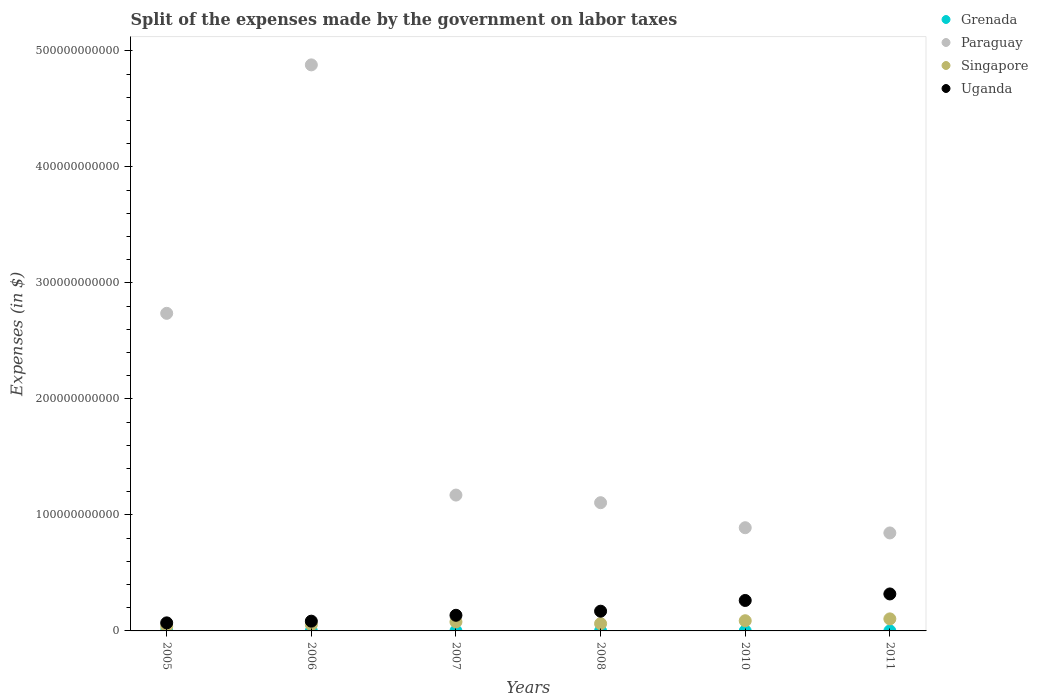What is the expenses made by the government on labor taxes in Grenada in 2008?
Your answer should be very brief. 2.60e+07. Across all years, what is the maximum expenses made by the government on labor taxes in Uganda?
Your response must be concise. 3.19e+1. Across all years, what is the minimum expenses made by the government on labor taxes in Grenada?
Provide a succinct answer. 1.49e+07. In which year was the expenses made by the government on labor taxes in Uganda maximum?
Ensure brevity in your answer.  2011. What is the total expenses made by the government on labor taxes in Paraguay in the graph?
Offer a terse response. 1.16e+12. What is the difference between the expenses made by the government on labor taxes in Singapore in 2008 and that in 2010?
Provide a short and direct response. -2.52e+09. What is the difference between the expenses made by the government on labor taxes in Paraguay in 2011 and the expenses made by the government on labor taxes in Uganda in 2005?
Keep it short and to the point. 7.75e+1. What is the average expenses made by the government on labor taxes in Paraguay per year?
Your answer should be very brief. 1.94e+11. In the year 2005, what is the difference between the expenses made by the government on labor taxes in Grenada and expenses made by the government on labor taxes in Singapore?
Your answer should be compact. -3.87e+09. In how many years, is the expenses made by the government on labor taxes in Grenada greater than 400000000000 $?
Give a very brief answer. 0. What is the ratio of the expenses made by the government on labor taxes in Paraguay in 2008 to that in 2011?
Make the answer very short. 1.31. Is the expenses made by the government on labor taxes in Singapore in 2010 less than that in 2011?
Your answer should be compact. Yes. What is the difference between the highest and the second highest expenses made by the government on labor taxes in Uganda?
Give a very brief answer. 5.62e+09. What is the difference between the highest and the lowest expenses made by the government on labor taxes in Paraguay?
Your answer should be very brief. 4.04e+11. Is it the case that in every year, the sum of the expenses made by the government on labor taxes in Singapore and expenses made by the government on labor taxes in Grenada  is greater than the sum of expenses made by the government on labor taxes in Uganda and expenses made by the government on labor taxes in Paraguay?
Offer a very short reply. No. Is it the case that in every year, the sum of the expenses made by the government on labor taxes in Paraguay and expenses made by the government on labor taxes in Uganda  is greater than the expenses made by the government on labor taxes in Grenada?
Offer a very short reply. Yes. Does the expenses made by the government on labor taxes in Grenada monotonically increase over the years?
Offer a terse response. No. Is the expenses made by the government on labor taxes in Grenada strictly less than the expenses made by the government on labor taxes in Uganda over the years?
Offer a very short reply. Yes. How many dotlines are there?
Ensure brevity in your answer.  4. How many years are there in the graph?
Your response must be concise. 6. What is the difference between two consecutive major ticks on the Y-axis?
Your answer should be compact. 1.00e+11. Are the values on the major ticks of Y-axis written in scientific E-notation?
Make the answer very short. No. How are the legend labels stacked?
Offer a terse response. Vertical. What is the title of the graph?
Your answer should be very brief. Split of the expenses made by the government on labor taxes. What is the label or title of the X-axis?
Your response must be concise. Years. What is the label or title of the Y-axis?
Offer a terse response. Expenses (in $). What is the Expenses (in $) in Grenada in 2005?
Your response must be concise. 1.54e+07. What is the Expenses (in $) of Paraguay in 2005?
Your answer should be very brief. 2.74e+11. What is the Expenses (in $) in Singapore in 2005?
Make the answer very short. 3.89e+09. What is the Expenses (in $) of Uganda in 2005?
Your answer should be very brief. 6.95e+09. What is the Expenses (in $) in Grenada in 2006?
Your response must be concise. 2.26e+07. What is the Expenses (in $) in Paraguay in 2006?
Provide a succinct answer. 4.88e+11. What is the Expenses (in $) in Singapore in 2006?
Provide a short and direct response. 5.35e+09. What is the Expenses (in $) of Uganda in 2006?
Provide a short and direct response. 8.41e+09. What is the Expenses (in $) in Grenada in 2007?
Your answer should be compact. 2.90e+07. What is the Expenses (in $) of Paraguay in 2007?
Your response must be concise. 1.17e+11. What is the Expenses (in $) in Singapore in 2007?
Make the answer very short. 7.79e+09. What is the Expenses (in $) of Uganda in 2007?
Your response must be concise. 1.35e+1. What is the Expenses (in $) in Grenada in 2008?
Provide a short and direct response. 2.60e+07. What is the Expenses (in $) of Paraguay in 2008?
Your answer should be very brief. 1.11e+11. What is the Expenses (in $) in Singapore in 2008?
Provide a succinct answer. 6.26e+09. What is the Expenses (in $) in Uganda in 2008?
Give a very brief answer. 1.70e+1. What is the Expenses (in $) in Grenada in 2010?
Provide a succinct answer. 1.74e+07. What is the Expenses (in $) of Paraguay in 2010?
Provide a short and direct response. 8.90e+1. What is the Expenses (in $) of Singapore in 2010?
Offer a terse response. 8.79e+09. What is the Expenses (in $) of Uganda in 2010?
Provide a short and direct response. 2.63e+1. What is the Expenses (in $) in Grenada in 2011?
Keep it short and to the point. 1.49e+07. What is the Expenses (in $) of Paraguay in 2011?
Provide a succinct answer. 8.45e+1. What is the Expenses (in $) in Singapore in 2011?
Keep it short and to the point. 1.04e+1. What is the Expenses (in $) of Uganda in 2011?
Make the answer very short. 3.19e+1. Across all years, what is the maximum Expenses (in $) of Grenada?
Provide a succinct answer. 2.90e+07. Across all years, what is the maximum Expenses (in $) in Paraguay?
Offer a very short reply. 4.88e+11. Across all years, what is the maximum Expenses (in $) of Singapore?
Ensure brevity in your answer.  1.04e+1. Across all years, what is the maximum Expenses (in $) in Uganda?
Your answer should be very brief. 3.19e+1. Across all years, what is the minimum Expenses (in $) in Grenada?
Your answer should be very brief. 1.49e+07. Across all years, what is the minimum Expenses (in $) in Paraguay?
Provide a succinct answer. 8.45e+1. Across all years, what is the minimum Expenses (in $) of Singapore?
Make the answer very short. 3.89e+09. Across all years, what is the minimum Expenses (in $) of Uganda?
Provide a succinct answer. 6.95e+09. What is the total Expenses (in $) in Grenada in the graph?
Provide a succinct answer. 1.25e+08. What is the total Expenses (in $) in Paraguay in the graph?
Keep it short and to the point. 1.16e+12. What is the total Expenses (in $) in Singapore in the graph?
Keep it short and to the point. 4.25e+1. What is the total Expenses (in $) in Uganda in the graph?
Ensure brevity in your answer.  1.04e+11. What is the difference between the Expenses (in $) in Grenada in 2005 and that in 2006?
Keep it short and to the point. -7.20e+06. What is the difference between the Expenses (in $) in Paraguay in 2005 and that in 2006?
Provide a short and direct response. -2.14e+11. What is the difference between the Expenses (in $) in Singapore in 2005 and that in 2006?
Your answer should be compact. -1.46e+09. What is the difference between the Expenses (in $) of Uganda in 2005 and that in 2006?
Make the answer very short. -1.47e+09. What is the difference between the Expenses (in $) in Grenada in 2005 and that in 2007?
Offer a very short reply. -1.36e+07. What is the difference between the Expenses (in $) of Paraguay in 2005 and that in 2007?
Keep it short and to the point. 1.57e+11. What is the difference between the Expenses (in $) of Singapore in 2005 and that in 2007?
Offer a terse response. -3.90e+09. What is the difference between the Expenses (in $) of Uganda in 2005 and that in 2007?
Keep it short and to the point. -6.53e+09. What is the difference between the Expenses (in $) in Grenada in 2005 and that in 2008?
Provide a short and direct response. -1.06e+07. What is the difference between the Expenses (in $) of Paraguay in 2005 and that in 2008?
Offer a terse response. 1.63e+11. What is the difference between the Expenses (in $) of Singapore in 2005 and that in 2008?
Your answer should be compact. -2.37e+09. What is the difference between the Expenses (in $) of Uganda in 2005 and that in 2008?
Your answer should be compact. -1.01e+1. What is the difference between the Expenses (in $) of Paraguay in 2005 and that in 2010?
Provide a short and direct response. 1.85e+11. What is the difference between the Expenses (in $) of Singapore in 2005 and that in 2010?
Provide a short and direct response. -4.90e+09. What is the difference between the Expenses (in $) in Uganda in 2005 and that in 2010?
Keep it short and to the point. -1.93e+1. What is the difference between the Expenses (in $) in Grenada in 2005 and that in 2011?
Offer a very short reply. 5.00e+05. What is the difference between the Expenses (in $) of Paraguay in 2005 and that in 2011?
Provide a succinct answer. 1.89e+11. What is the difference between the Expenses (in $) of Singapore in 2005 and that in 2011?
Make the answer very short. -6.49e+09. What is the difference between the Expenses (in $) of Uganda in 2005 and that in 2011?
Your answer should be compact. -2.49e+1. What is the difference between the Expenses (in $) of Grenada in 2006 and that in 2007?
Your answer should be very brief. -6.40e+06. What is the difference between the Expenses (in $) of Paraguay in 2006 and that in 2007?
Make the answer very short. 3.71e+11. What is the difference between the Expenses (in $) of Singapore in 2006 and that in 2007?
Give a very brief answer. -2.44e+09. What is the difference between the Expenses (in $) in Uganda in 2006 and that in 2007?
Offer a terse response. -5.06e+09. What is the difference between the Expenses (in $) of Grenada in 2006 and that in 2008?
Your answer should be very brief. -3.40e+06. What is the difference between the Expenses (in $) in Paraguay in 2006 and that in 2008?
Give a very brief answer. 3.77e+11. What is the difference between the Expenses (in $) of Singapore in 2006 and that in 2008?
Provide a succinct answer. -9.17e+08. What is the difference between the Expenses (in $) of Uganda in 2006 and that in 2008?
Offer a terse response. -8.60e+09. What is the difference between the Expenses (in $) of Grenada in 2006 and that in 2010?
Your response must be concise. 5.20e+06. What is the difference between the Expenses (in $) in Paraguay in 2006 and that in 2010?
Your answer should be compact. 3.99e+11. What is the difference between the Expenses (in $) of Singapore in 2006 and that in 2010?
Offer a very short reply. -3.44e+09. What is the difference between the Expenses (in $) in Uganda in 2006 and that in 2010?
Offer a terse response. -1.78e+1. What is the difference between the Expenses (in $) in Grenada in 2006 and that in 2011?
Your answer should be compact. 7.70e+06. What is the difference between the Expenses (in $) in Paraguay in 2006 and that in 2011?
Offer a very short reply. 4.04e+11. What is the difference between the Expenses (in $) in Singapore in 2006 and that in 2011?
Provide a short and direct response. -5.04e+09. What is the difference between the Expenses (in $) in Uganda in 2006 and that in 2011?
Give a very brief answer. -2.35e+1. What is the difference between the Expenses (in $) in Paraguay in 2007 and that in 2008?
Ensure brevity in your answer.  6.57e+09. What is the difference between the Expenses (in $) in Singapore in 2007 and that in 2008?
Your response must be concise. 1.53e+09. What is the difference between the Expenses (in $) in Uganda in 2007 and that in 2008?
Offer a very short reply. -3.54e+09. What is the difference between the Expenses (in $) of Grenada in 2007 and that in 2010?
Offer a terse response. 1.16e+07. What is the difference between the Expenses (in $) of Paraguay in 2007 and that in 2010?
Ensure brevity in your answer.  2.81e+1. What is the difference between the Expenses (in $) of Singapore in 2007 and that in 2010?
Give a very brief answer. -9.95e+08. What is the difference between the Expenses (in $) in Uganda in 2007 and that in 2010?
Keep it short and to the point. -1.28e+1. What is the difference between the Expenses (in $) in Grenada in 2007 and that in 2011?
Make the answer very short. 1.41e+07. What is the difference between the Expenses (in $) in Paraguay in 2007 and that in 2011?
Provide a short and direct response. 3.26e+1. What is the difference between the Expenses (in $) of Singapore in 2007 and that in 2011?
Your answer should be compact. -2.59e+09. What is the difference between the Expenses (in $) of Uganda in 2007 and that in 2011?
Ensure brevity in your answer.  -1.84e+1. What is the difference between the Expenses (in $) in Grenada in 2008 and that in 2010?
Keep it short and to the point. 8.60e+06. What is the difference between the Expenses (in $) in Paraguay in 2008 and that in 2010?
Provide a succinct answer. 2.16e+1. What is the difference between the Expenses (in $) in Singapore in 2008 and that in 2010?
Give a very brief answer. -2.52e+09. What is the difference between the Expenses (in $) of Uganda in 2008 and that in 2010?
Make the answer very short. -9.25e+09. What is the difference between the Expenses (in $) in Grenada in 2008 and that in 2011?
Make the answer very short. 1.11e+07. What is the difference between the Expenses (in $) of Paraguay in 2008 and that in 2011?
Make the answer very short. 2.61e+1. What is the difference between the Expenses (in $) in Singapore in 2008 and that in 2011?
Your answer should be very brief. -4.12e+09. What is the difference between the Expenses (in $) in Uganda in 2008 and that in 2011?
Your answer should be compact. -1.49e+1. What is the difference between the Expenses (in $) in Grenada in 2010 and that in 2011?
Provide a succinct answer. 2.50e+06. What is the difference between the Expenses (in $) in Paraguay in 2010 and that in 2011?
Make the answer very short. 4.50e+09. What is the difference between the Expenses (in $) of Singapore in 2010 and that in 2011?
Give a very brief answer. -1.60e+09. What is the difference between the Expenses (in $) of Uganda in 2010 and that in 2011?
Your response must be concise. -5.62e+09. What is the difference between the Expenses (in $) in Grenada in 2005 and the Expenses (in $) in Paraguay in 2006?
Make the answer very short. -4.88e+11. What is the difference between the Expenses (in $) of Grenada in 2005 and the Expenses (in $) of Singapore in 2006?
Provide a succinct answer. -5.33e+09. What is the difference between the Expenses (in $) of Grenada in 2005 and the Expenses (in $) of Uganda in 2006?
Make the answer very short. -8.40e+09. What is the difference between the Expenses (in $) in Paraguay in 2005 and the Expenses (in $) in Singapore in 2006?
Provide a short and direct response. 2.68e+11. What is the difference between the Expenses (in $) in Paraguay in 2005 and the Expenses (in $) in Uganda in 2006?
Provide a succinct answer. 2.65e+11. What is the difference between the Expenses (in $) of Singapore in 2005 and the Expenses (in $) of Uganda in 2006?
Provide a succinct answer. -4.52e+09. What is the difference between the Expenses (in $) of Grenada in 2005 and the Expenses (in $) of Paraguay in 2007?
Offer a terse response. -1.17e+11. What is the difference between the Expenses (in $) in Grenada in 2005 and the Expenses (in $) in Singapore in 2007?
Your response must be concise. -7.77e+09. What is the difference between the Expenses (in $) in Grenada in 2005 and the Expenses (in $) in Uganda in 2007?
Provide a short and direct response. -1.35e+1. What is the difference between the Expenses (in $) in Paraguay in 2005 and the Expenses (in $) in Singapore in 2007?
Offer a terse response. 2.66e+11. What is the difference between the Expenses (in $) in Paraguay in 2005 and the Expenses (in $) in Uganda in 2007?
Keep it short and to the point. 2.60e+11. What is the difference between the Expenses (in $) in Singapore in 2005 and the Expenses (in $) in Uganda in 2007?
Offer a terse response. -9.58e+09. What is the difference between the Expenses (in $) in Grenada in 2005 and the Expenses (in $) in Paraguay in 2008?
Your response must be concise. -1.11e+11. What is the difference between the Expenses (in $) of Grenada in 2005 and the Expenses (in $) of Singapore in 2008?
Provide a short and direct response. -6.25e+09. What is the difference between the Expenses (in $) of Grenada in 2005 and the Expenses (in $) of Uganda in 2008?
Offer a terse response. -1.70e+1. What is the difference between the Expenses (in $) in Paraguay in 2005 and the Expenses (in $) in Singapore in 2008?
Your answer should be compact. 2.68e+11. What is the difference between the Expenses (in $) in Paraguay in 2005 and the Expenses (in $) in Uganda in 2008?
Give a very brief answer. 2.57e+11. What is the difference between the Expenses (in $) of Singapore in 2005 and the Expenses (in $) of Uganda in 2008?
Give a very brief answer. -1.31e+1. What is the difference between the Expenses (in $) in Grenada in 2005 and the Expenses (in $) in Paraguay in 2010?
Your answer should be compact. -8.90e+1. What is the difference between the Expenses (in $) of Grenada in 2005 and the Expenses (in $) of Singapore in 2010?
Keep it short and to the point. -8.77e+09. What is the difference between the Expenses (in $) of Grenada in 2005 and the Expenses (in $) of Uganda in 2010?
Keep it short and to the point. -2.62e+1. What is the difference between the Expenses (in $) of Paraguay in 2005 and the Expenses (in $) of Singapore in 2010?
Provide a short and direct response. 2.65e+11. What is the difference between the Expenses (in $) of Paraguay in 2005 and the Expenses (in $) of Uganda in 2010?
Ensure brevity in your answer.  2.48e+11. What is the difference between the Expenses (in $) in Singapore in 2005 and the Expenses (in $) in Uganda in 2010?
Your answer should be very brief. -2.24e+1. What is the difference between the Expenses (in $) in Grenada in 2005 and the Expenses (in $) in Paraguay in 2011?
Offer a very short reply. -8.45e+1. What is the difference between the Expenses (in $) in Grenada in 2005 and the Expenses (in $) in Singapore in 2011?
Provide a succinct answer. -1.04e+1. What is the difference between the Expenses (in $) of Grenada in 2005 and the Expenses (in $) of Uganda in 2011?
Your response must be concise. -3.19e+1. What is the difference between the Expenses (in $) in Paraguay in 2005 and the Expenses (in $) in Singapore in 2011?
Your answer should be very brief. 2.63e+11. What is the difference between the Expenses (in $) of Paraguay in 2005 and the Expenses (in $) of Uganda in 2011?
Your answer should be very brief. 2.42e+11. What is the difference between the Expenses (in $) in Singapore in 2005 and the Expenses (in $) in Uganda in 2011?
Ensure brevity in your answer.  -2.80e+1. What is the difference between the Expenses (in $) in Grenada in 2006 and the Expenses (in $) in Paraguay in 2007?
Offer a terse response. -1.17e+11. What is the difference between the Expenses (in $) of Grenada in 2006 and the Expenses (in $) of Singapore in 2007?
Offer a very short reply. -7.77e+09. What is the difference between the Expenses (in $) of Grenada in 2006 and the Expenses (in $) of Uganda in 2007?
Make the answer very short. -1.35e+1. What is the difference between the Expenses (in $) in Paraguay in 2006 and the Expenses (in $) in Singapore in 2007?
Provide a succinct answer. 4.80e+11. What is the difference between the Expenses (in $) of Paraguay in 2006 and the Expenses (in $) of Uganda in 2007?
Provide a succinct answer. 4.75e+11. What is the difference between the Expenses (in $) of Singapore in 2006 and the Expenses (in $) of Uganda in 2007?
Offer a very short reply. -8.13e+09. What is the difference between the Expenses (in $) of Grenada in 2006 and the Expenses (in $) of Paraguay in 2008?
Your answer should be very brief. -1.11e+11. What is the difference between the Expenses (in $) in Grenada in 2006 and the Expenses (in $) in Singapore in 2008?
Provide a succinct answer. -6.24e+09. What is the difference between the Expenses (in $) of Grenada in 2006 and the Expenses (in $) of Uganda in 2008?
Keep it short and to the point. -1.70e+1. What is the difference between the Expenses (in $) of Paraguay in 2006 and the Expenses (in $) of Singapore in 2008?
Keep it short and to the point. 4.82e+11. What is the difference between the Expenses (in $) in Paraguay in 2006 and the Expenses (in $) in Uganda in 2008?
Ensure brevity in your answer.  4.71e+11. What is the difference between the Expenses (in $) of Singapore in 2006 and the Expenses (in $) of Uganda in 2008?
Keep it short and to the point. -1.17e+1. What is the difference between the Expenses (in $) of Grenada in 2006 and the Expenses (in $) of Paraguay in 2010?
Offer a very short reply. -8.90e+1. What is the difference between the Expenses (in $) of Grenada in 2006 and the Expenses (in $) of Singapore in 2010?
Provide a succinct answer. -8.76e+09. What is the difference between the Expenses (in $) in Grenada in 2006 and the Expenses (in $) in Uganda in 2010?
Keep it short and to the point. -2.62e+1. What is the difference between the Expenses (in $) of Paraguay in 2006 and the Expenses (in $) of Singapore in 2010?
Offer a terse response. 4.79e+11. What is the difference between the Expenses (in $) in Paraguay in 2006 and the Expenses (in $) in Uganda in 2010?
Offer a terse response. 4.62e+11. What is the difference between the Expenses (in $) in Singapore in 2006 and the Expenses (in $) in Uganda in 2010?
Ensure brevity in your answer.  -2.09e+1. What is the difference between the Expenses (in $) in Grenada in 2006 and the Expenses (in $) in Paraguay in 2011?
Offer a terse response. -8.44e+1. What is the difference between the Expenses (in $) in Grenada in 2006 and the Expenses (in $) in Singapore in 2011?
Keep it short and to the point. -1.04e+1. What is the difference between the Expenses (in $) in Grenada in 2006 and the Expenses (in $) in Uganda in 2011?
Make the answer very short. -3.19e+1. What is the difference between the Expenses (in $) of Paraguay in 2006 and the Expenses (in $) of Singapore in 2011?
Your answer should be very brief. 4.78e+11. What is the difference between the Expenses (in $) of Paraguay in 2006 and the Expenses (in $) of Uganda in 2011?
Your answer should be compact. 4.56e+11. What is the difference between the Expenses (in $) in Singapore in 2006 and the Expenses (in $) in Uganda in 2011?
Keep it short and to the point. -2.65e+1. What is the difference between the Expenses (in $) in Grenada in 2007 and the Expenses (in $) in Paraguay in 2008?
Provide a succinct answer. -1.11e+11. What is the difference between the Expenses (in $) in Grenada in 2007 and the Expenses (in $) in Singapore in 2008?
Ensure brevity in your answer.  -6.24e+09. What is the difference between the Expenses (in $) of Grenada in 2007 and the Expenses (in $) of Uganda in 2008?
Ensure brevity in your answer.  -1.70e+1. What is the difference between the Expenses (in $) of Paraguay in 2007 and the Expenses (in $) of Singapore in 2008?
Ensure brevity in your answer.  1.11e+11. What is the difference between the Expenses (in $) of Paraguay in 2007 and the Expenses (in $) of Uganda in 2008?
Your answer should be compact. 1.00e+11. What is the difference between the Expenses (in $) in Singapore in 2007 and the Expenses (in $) in Uganda in 2008?
Give a very brief answer. -9.22e+09. What is the difference between the Expenses (in $) in Grenada in 2007 and the Expenses (in $) in Paraguay in 2010?
Your answer should be compact. -8.89e+1. What is the difference between the Expenses (in $) in Grenada in 2007 and the Expenses (in $) in Singapore in 2010?
Give a very brief answer. -8.76e+09. What is the difference between the Expenses (in $) in Grenada in 2007 and the Expenses (in $) in Uganda in 2010?
Keep it short and to the point. -2.62e+1. What is the difference between the Expenses (in $) in Paraguay in 2007 and the Expenses (in $) in Singapore in 2010?
Make the answer very short. 1.08e+11. What is the difference between the Expenses (in $) in Paraguay in 2007 and the Expenses (in $) in Uganda in 2010?
Give a very brief answer. 9.09e+1. What is the difference between the Expenses (in $) of Singapore in 2007 and the Expenses (in $) of Uganda in 2010?
Make the answer very short. -1.85e+1. What is the difference between the Expenses (in $) of Grenada in 2007 and the Expenses (in $) of Paraguay in 2011?
Your response must be concise. -8.44e+1. What is the difference between the Expenses (in $) of Grenada in 2007 and the Expenses (in $) of Singapore in 2011?
Ensure brevity in your answer.  -1.04e+1. What is the difference between the Expenses (in $) in Grenada in 2007 and the Expenses (in $) in Uganda in 2011?
Make the answer very short. -3.18e+1. What is the difference between the Expenses (in $) in Paraguay in 2007 and the Expenses (in $) in Singapore in 2011?
Your response must be concise. 1.07e+11. What is the difference between the Expenses (in $) in Paraguay in 2007 and the Expenses (in $) in Uganda in 2011?
Your response must be concise. 8.52e+1. What is the difference between the Expenses (in $) of Singapore in 2007 and the Expenses (in $) of Uganda in 2011?
Provide a short and direct response. -2.41e+1. What is the difference between the Expenses (in $) in Grenada in 2008 and the Expenses (in $) in Paraguay in 2010?
Give a very brief answer. -8.89e+1. What is the difference between the Expenses (in $) in Grenada in 2008 and the Expenses (in $) in Singapore in 2010?
Provide a short and direct response. -8.76e+09. What is the difference between the Expenses (in $) in Grenada in 2008 and the Expenses (in $) in Uganda in 2010?
Offer a terse response. -2.62e+1. What is the difference between the Expenses (in $) in Paraguay in 2008 and the Expenses (in $) in Singapore in 2010?
Offer a terse response. 1.02e+11. What is the difference between the Expenses (in $) of Paraguay in 2008 and the Expenses (in $) of Uganda in 2010?
Your answer should be compact. 8.43e+1. What is the difference between the Expenses (in $) of Singapore in 2008 and the Expenses (in $) of Uganda in 2010?
Offer a very short reply. -2.00e+1. What is the difference between the Expenses (in $) in Grenada in 2008 and the Expenses (in $) in Paraguay in 2011?
Ensure brevity in your answer.  -8.44e+1. What is the difference between the Expenses (in $) in Grenada in 2008 and the Expenses (in $) in Singapore in 2011?
Your response must be concise. -1.04e+1. What is the difference between the Expenses (in $) in Grenada in 2008 and the Expenses (in $) in Uganda in 2011?
Offer a very short reply. -3.18e+1. What is the difference between the Expenses (in $) in Paraguay in 2008 and the Expenses (in $) in Singapore in 2011?
Provide a short and direct response. 1.00e+11. What is the difference between the Expenses (in $) of Paraguay in 2008 and the Expenses (in $) of Uganda in 2011?
Offer a very short reply. 7.87e+1. What is the difference between the Expenses (in $) in Singapore in 2008 and the Expenses (in $) in Uganda in 2011?
Your answer should be compact. -2.56e+1. What is the difference between the Expenses (in $) in Grenada in 2010 and the Expenses (in $) in Paraguay in 2011?
Your answer should be very brief. -8.45e+1. What is the difference between the Expenses (in $) in Grenada in 2010 and the Expenses (in $) in Singapore in 2011?
Keep it short and to the point. -1.04e+1. What is the difference between the Expenses (in $) in Grenada in 2010 and the Expenses (in $) in Uganda in 2011?
Your response must be concise. -3.19e+1. What is the difference between the Expenses (in $) in Paraguay in 2010 and the Expenses (in $) in Singapore in 2011?
Keep it short and to the point. 7.86e+1. What is the difference between the Expenses (in $) of Paraguay in 2010 and the Expenses (in $) of Uganda in 2011?
Make the answer very short. 5.71e+1. What is the difference between the Expenses (in $) of Singapore in 2010 and the Expenses (in $) of Uganda in 2011?
Provide a short and direct response. -2.31e+1. What is the average Expenses (in $) in Grenada per year?
Your answer should be very brief. 2.09e+07. What is the average Expenses (in $) in Paraguay per year?
Provide a succinct answer. 1.94e+11. What is the average Expenses (in $) in Singapore per year?
Your answer should be compact. 7.08e+09. What is the average Expenses (in $) of Uganda per year?
Your response must be concise. 1.73e+1. In the year 2005, what is the difference between the Expenses (in $) of Grenada and Expenses (in $) of Paraguay?
Your answer should be very brief. -2.74e+11. In the year 2005, what is the difference between the Expenses (in $) in Grenada and Expenses (in $) in Singapore?
Keep it short and to the point. -3.87e+09. In the year 2005, what is the difference between the Expenses (in $) of Grenada and Expenses (in $) of Uganda?
Your answer should be very brief. -6.93e+09. In the year 2005, what is the difference between the Expenses (in $) of Paraguay and Expenses (in $) of Singapore?
Provide a short and direct response. 2.70e+11. In the year 2005, what is the difference between the Expenses (in $) in Paraguay and Expenses (in $) in Uganda?
Ensure brevity in your answer.  2.67e+11. In the year 2005, what is the difference between the Expenses (in $) in Singapore and Expenses (in $) in Uganda?
Ensure brevity in your answer.  -3.06e+09. In the year 2006, what is the difference between the Expenses (in $) of Grenada and Expenses (in $) of Paraguay?
Offer a very short reply. -4.88e+11. In the year 2006, what is the difference between the Expenses (in $) of Grenada and Expenses (in $) of Singapore?
Your answer should be very brief. -5.32e+09. In the year 2006, what is the difference between the Expenses (in $) of Grenada and Expenses (in $) of Uganda?
Make the answer very short. -8.39e+09. In the year 2006, what is the difference between the Expenses (in $) in Paraguay and Expenses (in $) in Singapore?
Offer a terse response. 4.83e+11. In the year 2006, what is the difference between the Expenses (in $) of Paraguay and Expenses (in $) of Uganda?
Keep it short and to the point. 4.80e+11. In the year 2006, what is the difference between the Expenses (in $) of Singapore and Expenses (in $) of Uganda?
Offer a very short reply. -3.07e+09. In the year 2007, what is the difference between the Expenses (in $) of Grenada and Expenses (in $) of Paraguay?
Ensure brevity in your answer.  -1.17e+11. In the year 2007, what is the difference between the Expenses (in $) in Grenada and Expenses (in $) in Singapore?
Your answer should be compact. -7.76e+09. In the year 2007, what is the difference between the Expenses (in $) of Grenada and Expenses (in $) of Uganda?
Provide a succinct answer. -1.34e+1. In the year 2007, what is the difference between the Expenses (in $) in Paraguay and Expenses (in $) in Singapore?
Give a very brief answer. 1.09e+11. In the year 2007, what is the difference between the Expenses (in $) of Paraguay and Expenses (in $) of Uganda?
Make the answer very short. 1.04e+11. In the year 2007, what is the difference between the Expenses (in $) of Singapore and Expenses (in $) of Uganda?
Provide a short and direct response. -5.68e+09. In the year 2008, what is the difference between the Expenses (in $) in Grenada and Expenses (in $) in Paraguay?
Offer a very short reply. -1.11e+11. In the year 2008, what is the difference between the Expenses (in $) of Grenada and Expenses (in $) of Singapore?
Your answer should be compact. -6.24e+09. In the year 2008, what is the difference between the Expenses (in $) of Grenada and Expenses (in $) of Uganda?
Your answer should be very brief. -1.70e+1. In the year 2008, what is the difference between the Expenses (in $) of Paraguay and Expenses (in $) of Singapore?
Ensure brevity in your answer.  1.04e+11. In the year 2008, what is the difference between the Expenses (in $) in Paraguay and Expenses (in $) in Uganda?
Provide a short and direct response. 9.35e+1. In the year 2008, what is the difference between the Expenses (in $) of Singapore and Expenses (in $) of Uganda?
Give a very brief answer. -1.07e+1. In the year 2010, what is the difference between the Expenses (in $) in Grenada and Expenses (in $) in Paraguay?
Give a very brief answer. -8.90e+1. In the year 2010, what is the difference between the Expenses (in $) of Grenada and Expenses (in $) of Singapore?
Keep it short and to the point. -8.77e+09. In the year 2010, what is the difference between the Expenses (in $) of Grenada and Expenses (in $) of Uganda?
Make the answer very short. -2.62e+1. In the year 2010, what is the difference between the Expenses (in $) in Paraguay and Expenses (in $) in Singapore?
Give a very brief answer. 8.02e+1. In the year 2010, what is the difference between the Expenses (in $) of Paraguay and Expenses (in $) of Uganda?
Your answer should be very brief. 6.27e+1. In the year 2010, what is the difference between the Expenses (in $) of Singapore and Expenses (in $) of Uganda?
Your response must be concise. -1.75e+1. In the year 2011, what is the difference between the Expenses (in $) of Grenada and Expenses (in $) of Paraguay?
Your answer should be very brief. -8.45e+1. In the year 2011, what is the difference between the Expenses (in $) of Grenada and Expenses (in $) of Singapore?
Give a very brief answer. -1.04e+1. In the year 2011, what is the difference between the Expenses (in $) in Grenada and Expenses (in $) in Uganda?
Offer a terse response. -3.19e+1. In the year 2011, what is the difference between the Expenses (in $) of Paraguay and Expenses (in $) of Singapore?
Make the answer very short. 7.41e+1. In the year 2011, what is the difference between the Expenses (in $) of Paraguay and Expenses (in $) of Uganda?
Your answer should be very brief. 5.26e+1. In the year 2011, what is the difference between the Expenses (in $) in Singapore and Expenses (in $) in Uganda?
Your answer should be compact. -2.15e+1. What is the ratio of the Expenses (in $) of Grenada in 2005 to that in 2006?
Offer a very short reply. 0.68. What is the ratio of the Expenses (in $) in Paraguay in 2005 to that in 2006?
Keep it short and to the point. 0.56. What is the ratio of the Expenses (in $) in Singapore in 2005 to that in 2006?
Provide a succinct answer. 0.73. What is the ratio of the Expenses (in $) in Uganda in 2005 to that in 2006?
Offer a terse response. 0.83. What is the ratio of the Expenses (in $) in Grenada in 2005 to that in 2007?
Give a very brief answer. 0.53. What is the ratio of the Expenses (in $) in Paraguay in 2005 to that in 2007?
Your response must be concise. 2.34. What is the ratio of the Expenses (in $) in Singapore in 2005 to that in 2007?
Ensure brevity in your answer.  0.5. What is the ratio of the Expenses (in $) of Uganda in 2005 to that in 2007?
Your answer should be compact. 0.52. What is the ratio of the Expenses (in $) of Grenada in 2005 to that in 2008?
Make the answer very short. 0.59. What is the ratio of the Expenses (in $) of Paraguay in 2005 to that in 2008?
Make the answer very short. 2.48. What is the ratio of the Expenses (in $) of Singapore in 2005 to that in 2008?
Your answer should be very brief. 0.62. What is the ratio of the Expenses (in $) in Uganda in 2005 to that in 2008?
Your response must be concise. 0.41. What is the ratio of the Expenses (in $) of Grenada in 2005 to that in 2010?
Provide a succinct answer. 0.89. What is the ratio of the Expenses (in $) of Paraguay in 2005 to that in 2010?
Make the answer very short. 3.08. What is the ratio of the Expenses (in $) in Singapore in 2005 to that in 2010?
Offer a very short reply. 0.44. What is the ratio of the Expenses (in $) in Uganda in 2005 to that in 2010?
Offer a terse response. 0.26. What is the ratio of the Expenses (in $) of Grenada in 2005 to that in 2011?
Offer a very short reply. 1.03. What is the ratio of the Expenses (in $) in Paraguay in 2005 to that in 2011?
Your response must be concise. 3.24. What is the ratio of the Expenses (in $) of Singapore in 2005 to that in 2011?
Your answer should be compact. 0.37. What is the ratio of the Expenses (in $) in Uganda in 2005 to that in 2011?
Your answer should be very brief. 0.22. What is the ratio of the Expenses (in $) of Grenada in 2006 to that in 2007?
Ensure brevity in your answer.  0.78. What is the ratio of the Expenses (in $) in Paraguay in 2006 to that in 2007?
Offer a very short reply. 4.17. What is the ratio of the Expenses (in $) in Singapore in 2006 to that in 2007?
Your answer should be very brief. 0.69. What is the ratio of the Expenses (in $) in Uganda in 2006 to that in 2007?
Your answer should be very brief. 0.62. What is the ratio of the Expenses (in $) of Grenada in 2006 to that in 2008?
Your answer should be very brief. 0.87. What is the ratio of the Expenses (in $) in Paraguay in 2006 to that in 2008?
Your answer should be very brief. 4.41. What is the ratio of the Expenses (in $) in Singapore in 2006 to that in 2008?
Offer a very short reply. 0.85. What is the ratio of the Expenses (in $) of Uganda in 2006 to that in 2008?
Provide a short and direct response. 0.49. What is the ratio of the Expenses (in $) of Grenada in 2006 to that in 2010?
Provide a succinct answer. 1.3. What is the ratio of the Expenses (in $) of Paraguay in 2006 to that in 2010?
Keep it short and to the point. 5.48. What is the ratio of the Expenses (in $) in Singapore in 2006 to that in 2010?
Make the answer very short. 0.61. What is the ratio of the Expenses (in $) in Uganda in 2006 to that in 2010?
Make the answer very short. 0.32. What is the ratio of the Expenses (in $) of Grenada in 2006 to that in 2011?
Ensure brevity in your answer.  1.52. What is the ratio of the Expenses (in $) in Paraguay in 2006 to that in 2011?
Keep it short and to the point. 5.78. What is the ratio of the Expenses (in $) of Singapore in 2006 to that in 2011?
Provide a short and direct response. 0.51. What is the ratio of the Expenses (in $) of Uganda in 2006 to that in 2011?
Provide a succinct answer. 0.26. What is the ratio of the Expenses (in $) of Grenada in 2007 to that in 2008?
Your answer should be compact. 1.12. What is the ratio of the Expenses (in $) in Paraguay in 2007 to that in 2008?
Keep it short and to the point. 1.06. What is the ratio of the Expenses (in $) of Singapore in 2007 to that in 2008?
Your answer should be very brief. 1.24. What is the ratio of the Expenses (in $) of Uganda in 2007 to that in 2008?
Give a very brief answer. 0.79. What is the ratio of the Expenses (in $) in Grenada in 2007 to that in 2010?
Give a very brief answer. 1.67. What is the ratio of the Expenses (in $) of Paraguay in 2007 to that in 2010?
Keep it short and to the point. 1.32. What is the ratio of the Expenses (in $) of Singapore in 2007 to that in 2010?
Provide a succinct answer. 0.89. What is the ratio of the Expenses (in $) in Uganda in 2007 to that in 2010?
Your answer should be very brief. 0.51. What is the ratio of the Expenses (in $) in Grenada in 2007 to that in 2011?
Provide a succinct answer. 1.95. What is the ratio of the Expenses (in $) of Paraguay in 2007 to that in 2011?
Ensure brevity in your answer.  1.39. What is the ratio of the Expenses (in $) in Singapore in 2007 to that in 2011?
Provide a succinct answer. 0.75. What is the ratio of the Expenses (in $) of Uganda in 2007 to that in 2011?
Offer a very short reply. 0.42. What is the ratio of the Expenses (in $) of Grenada in 2008 to that in 2010?
Ensure brevity in your answer.  1.49. What is the ratio of the Expenses (in $) of Paraguay in 2008 to that in 2010?
Make the answer very short. 1.24. What is the ratio of the Expenses (in $) in Singapore in 2008 to that in 2010?
Offer a terse response. 0.71. What is the ratio of the Expenses (in $) in Uganda in 2008 to that in 2010?
Ensure brevity in your answer.  0.65. What is the ratio of the Expenses (in $) of Grenada in 2008 to that in 2011?
Provide a short and direct response. 1.75. What is the ratio of the Expenses (in $) of Paraguay in 2008 to that in 2011?
Your response must be concise. 1.31. What is the ratio of the Expenses (in $) in Singapore in 2008 to that in 2011?
Your answer should be very brief. 0.6. What is the ratio of the Expenses (in $) of Uganda in 2008 to that in 2011?
Offer a very short reply. 0.53. What is the ratio of the Expenses (in $) in Grenada in 2010 to that in 2011?
Ensure brevity in your answer.  1.17. What is the ratio of the Expenses (in $) in Paraguay in 2010 to that in 2011?
Ensure brevity in your answer.  1.05. What is the ratio of the Expenses (in $) in Singapore in 2010 to that in 2011?
Your answer should be very brief. 0.85. What is the ratio of the Expenses (in $) in Uganda in 2010 to that in 2011?
Give a very brief answer. 0.82. What is the difference between the highest and the second highest Expenses (in $) in Paraguay?
Offer a very short reply. 2.14e+11. What is the difference between the highest and the second highest Expenses (in $) of Singapore?
Ensure brevity in your answer.  1.60e+09. What is the difference between the highest and the second highest Expenses (in $) in Uganda?
Offer a terse response. 5.62e+09. What is the difference between the highest and the lowest Expenses (in $) in Grenada?
Your answer should be very brief. 1.41e+07. What is the difference between the highest and the lowest Expenses (in $) of Paraguay?
Offer a terse response. 4.04e+11. What is the difference between the highest and the lowest Expenses (in $) in Singapore?
Offer a very short reply. 6.49e+09. What is the difference between the highest and the lowest Expenses (in $) of Uganda?
Give a very brief answer. 2.49e+1. 